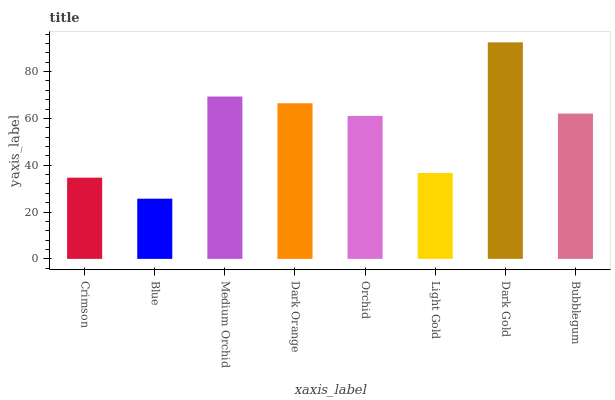Is Medium Orchid the minimum?
Answer yes or no. No. Is Medium Orchid the maximum?
Answer yes or no. No. Is Medium Orchid greater than Blue?
Answer yes or no. Yes. Is Blue less than Medium Orchid?
Answer yes or no. Yes. Is Blue greater than Medium Orchid?
Answer yes or no. No. Is Medium Orchid less than Blue?
Answer yes or no. No. Is Bubblegum the high median?
Answer yes or no. Yes. Is Orchid the low median?
Answer yes or no. Yes. Is Dark Gold the high median?
Answer yes or no. No. Is Dark Gold the low median?
Answer yes or no. No. 